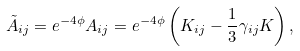<formula> <loc_0><loc_0><loc_500><loc_500>\tilde { A } _ { i j } = e ^ { - 4 \phi } A _ { i j } = e ^ { - 4 \phi } \left ( K _ { i j } - \frac { 1 } { 3 } \gamma _ { i j } K \right ) ,</formula> 